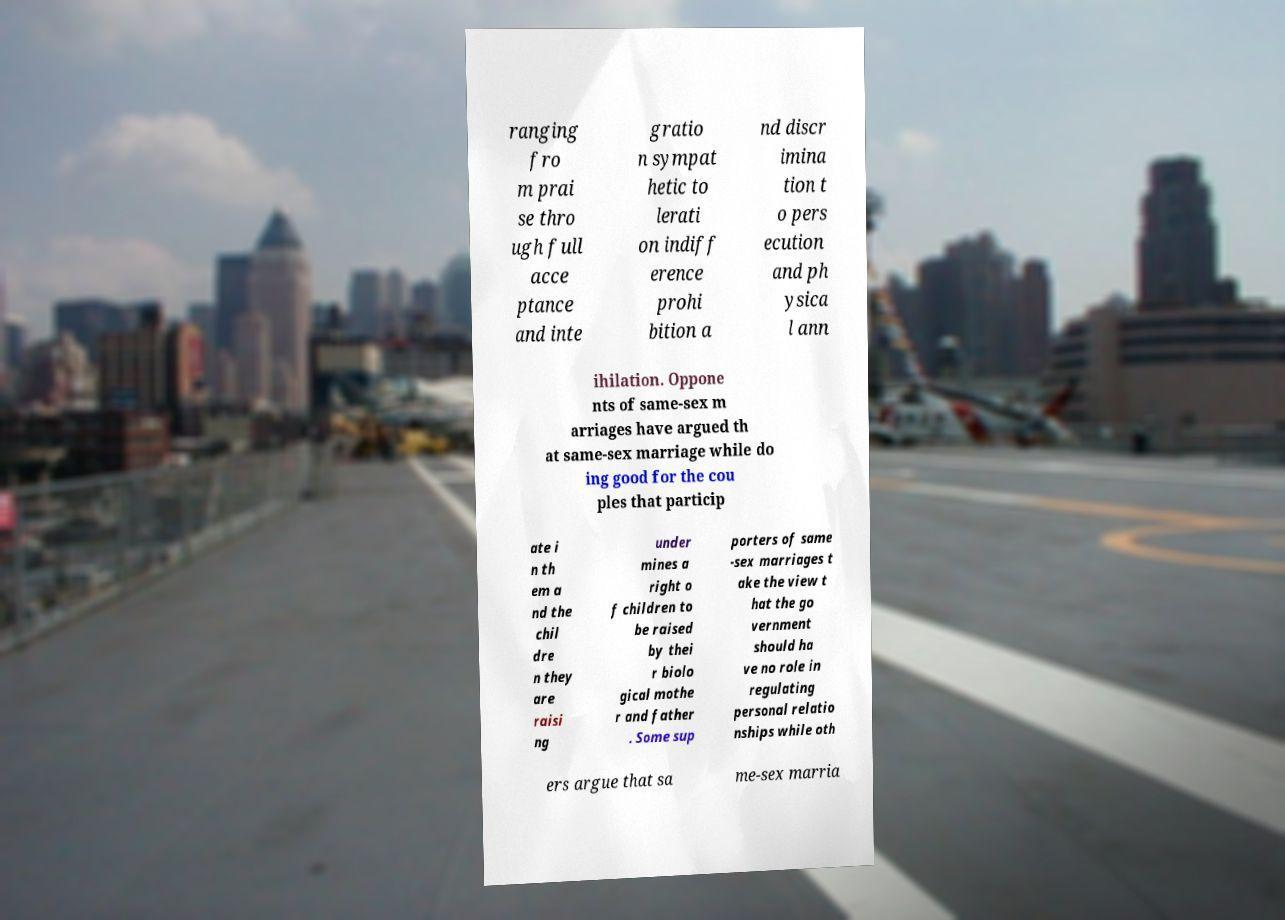Could you assist in decoding the text presented in this image and type it out clearly? ranging fro m prai se thro ugh full acce ptance and inte gratio n sympat hetic to lerati on indiff erence prohi bition a nd discr imina tion t o pers ecution and ph ysica l ann ihilation. Oppone nts of same-sex m arriages have argued th at same-sex marriage while do ing good for the cou ples that particip ate i n th em a nd the chil dre n they are raisi ng under mines a right o f children to be raised by thei r biolo gical mothe r and father . Some sup porters of same -sex marriages t ake the view t hat the go vernment should ha ve no role in regulating personal relatio nships while oth ers argue that sa me-sex marria 